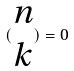<formula> <loc_0><loc_0><loc_500><loc_500>( \begin{matrix} n \\ k \end{matrix} ) = 0</formula> 